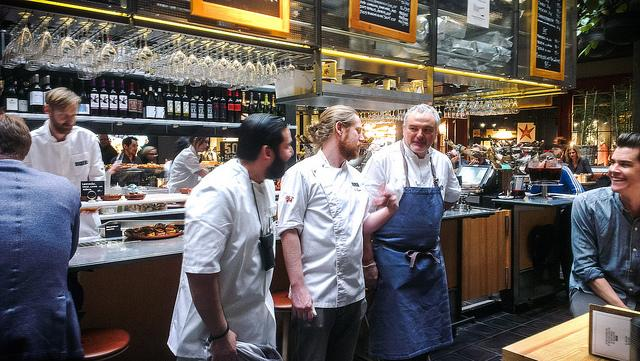What profession are the men wearing aprons? Please explain your reasoning. cooks. The people are cooks in a restaurant. 